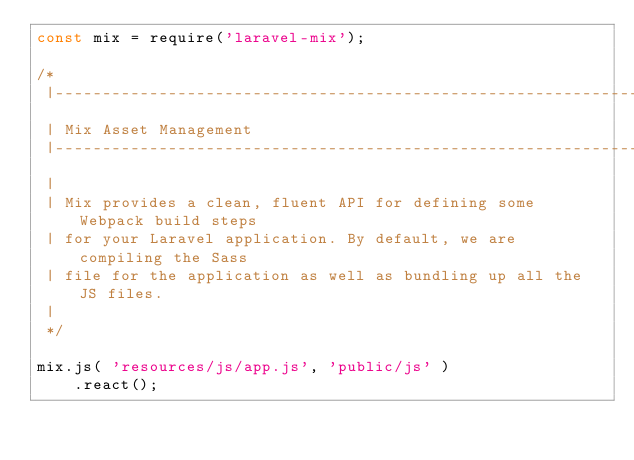<code> <loc_0><loc_0><loc_500><loc_500><_JavaScript_>const mix = require('laravel-mix');

/*
 |--------------------------------------------------------------------------
 | Mix Asset Management
 |--------------------------------------------------------------------------
 |
 | Mix provides a clean, fluent API for defining some Webpack build steps
 | for your Laravel application. By default, we are compiling the Sass
 | file for the application as well as bundling up all the JS files.
 |
 */

mix.js( 'resources/js/app.js', 'public/js' )
    .react();</code> 